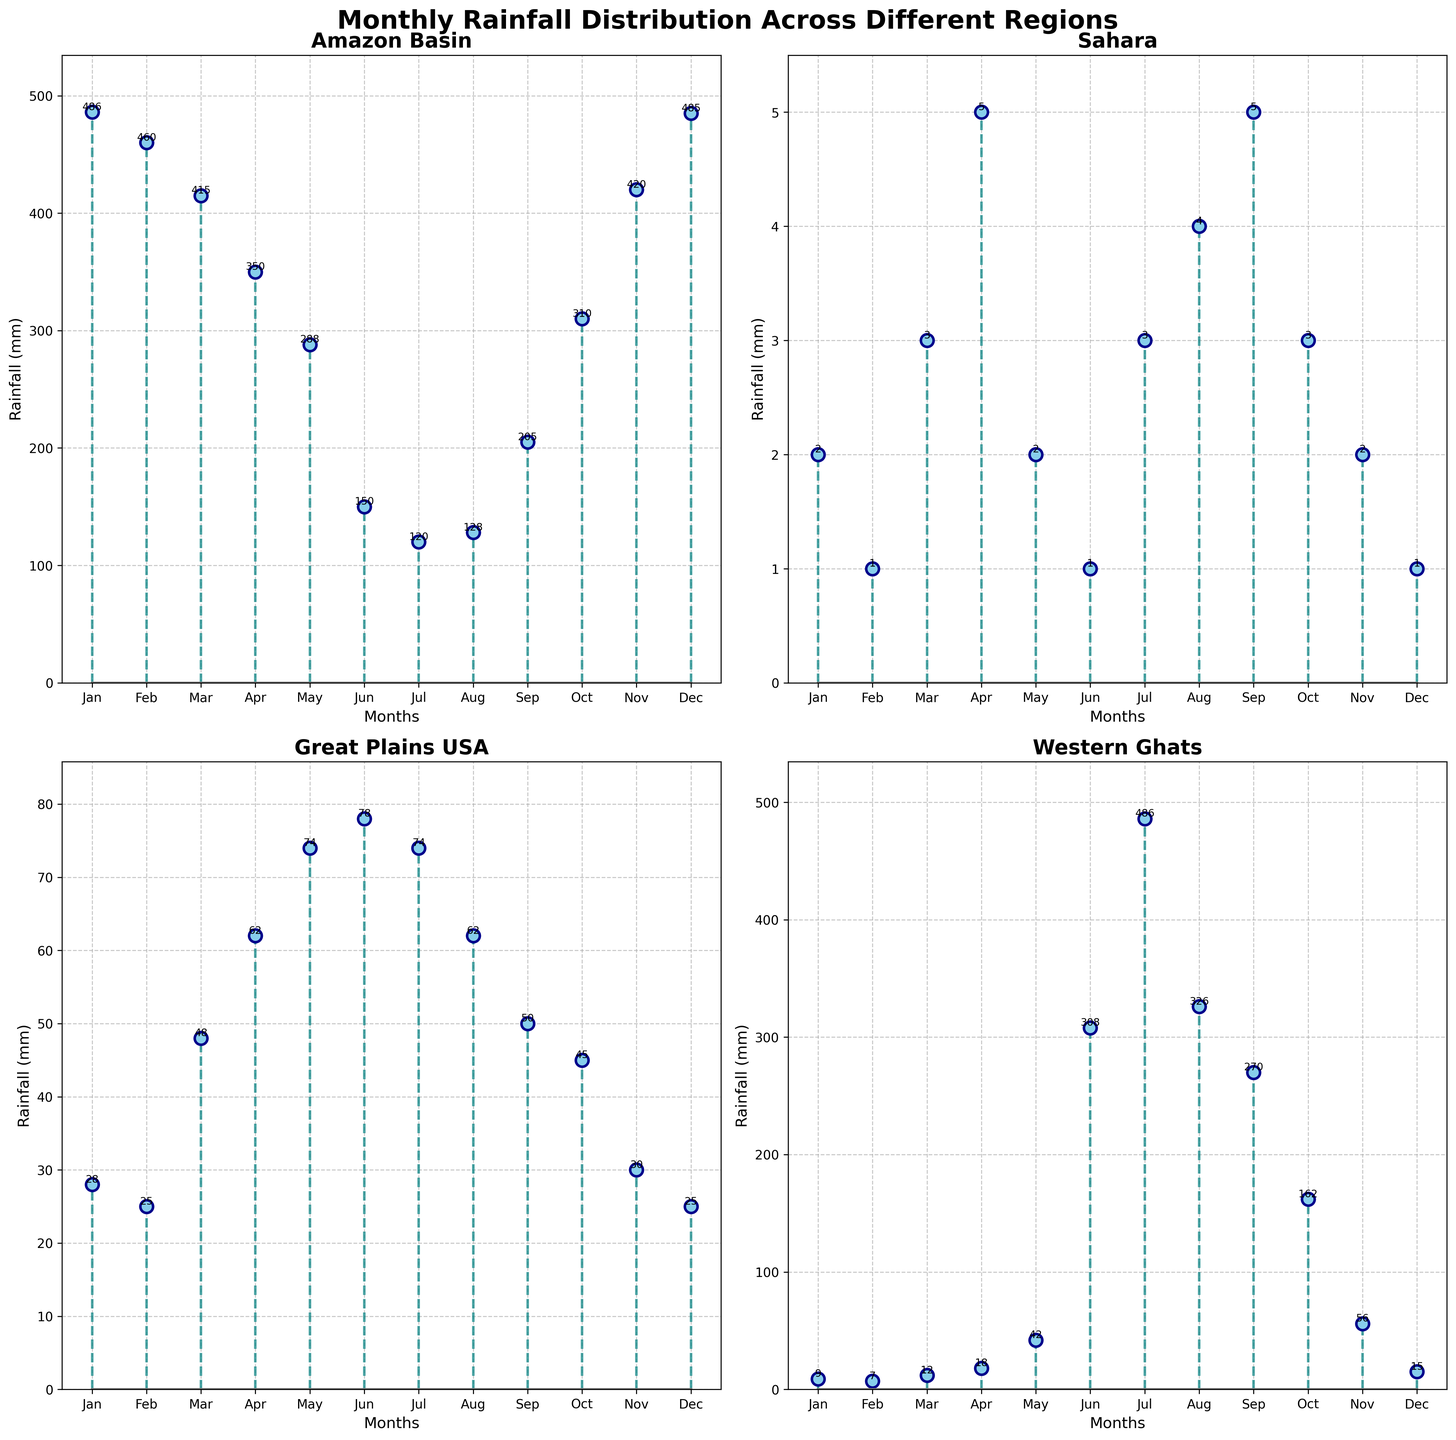What is the title of the figure? The title is provided at the top of the figure, usually in a larger and bolder font. It says "Monthly Rainfall Distribution Across Different Regions".
Answer: Monthly Rainfall Distribution Across Different Regions Which region has the highest rainfall in July? To determine this, look for the highest stem in July across all subplots. The plot for the Western Ghats shows a rainfall of 486 mm in July, the highest among all regions.
Answer: Western Ghats How many regions are plotted on the figure? Count the number of subplots within the figure. Each subplot represents a different region. There are 4 subplots, indicating 4 regions.
Answer: 4 What is the rainfall difference between June and December in the Sahara region? Find and subtract the rainfall values for June and December within the Sahara subplot. June has 1 mm and December has 1 mm, so the difference is 0 mm.
Answer: 0 mm Which month has the lowest rainfall in the Amazon Basin, and what is the amount? Locate the Amazon Basin subplot and identify the smallest stem. July shows the lowest rainfall at 120 mm.
Answer: July, 120 mm Compare the rainfall in March between the Great Plains USA and the Western Ghats. Which region received more rainfall, and by how much? Look at the March data points in both the Great Plains USA and Western Ghats subplots. Great Plains USA has 48 mm and Western Ghats has 12 mm. Subtract to find the difference, 48 mm - 12 mm = 36 mm.
Answer: Great Plains USA, 36 mm Does any region show a consistent increasing trend in rainfall from January to December? Inspect each subplot's trend line from January to December. Neither region shows a consistent increasing trend; all have fluctuations.
Answer: No What’s the average rainfall in the Amazon Basin during the first three months of the year? Take the rainfall values for January, February, and March in the Amazon Basin subplot: 486, 460, and 415 mm. Sum these values (486 + 460 + 415 = 1361 mm) and divide by 3 for the average.
Answer: 453.67 mm Identify the region with the most significant seasonal variation (difference between maximum and minimum rainfall), and state the amounts. Examine the subplots for the maximum to minimum difference in each region. The Western Ghats have the highest variation: 486 mm (July) - 7 mm (February) = 479 mm.
Answer: Western Ghats, 479 mm 